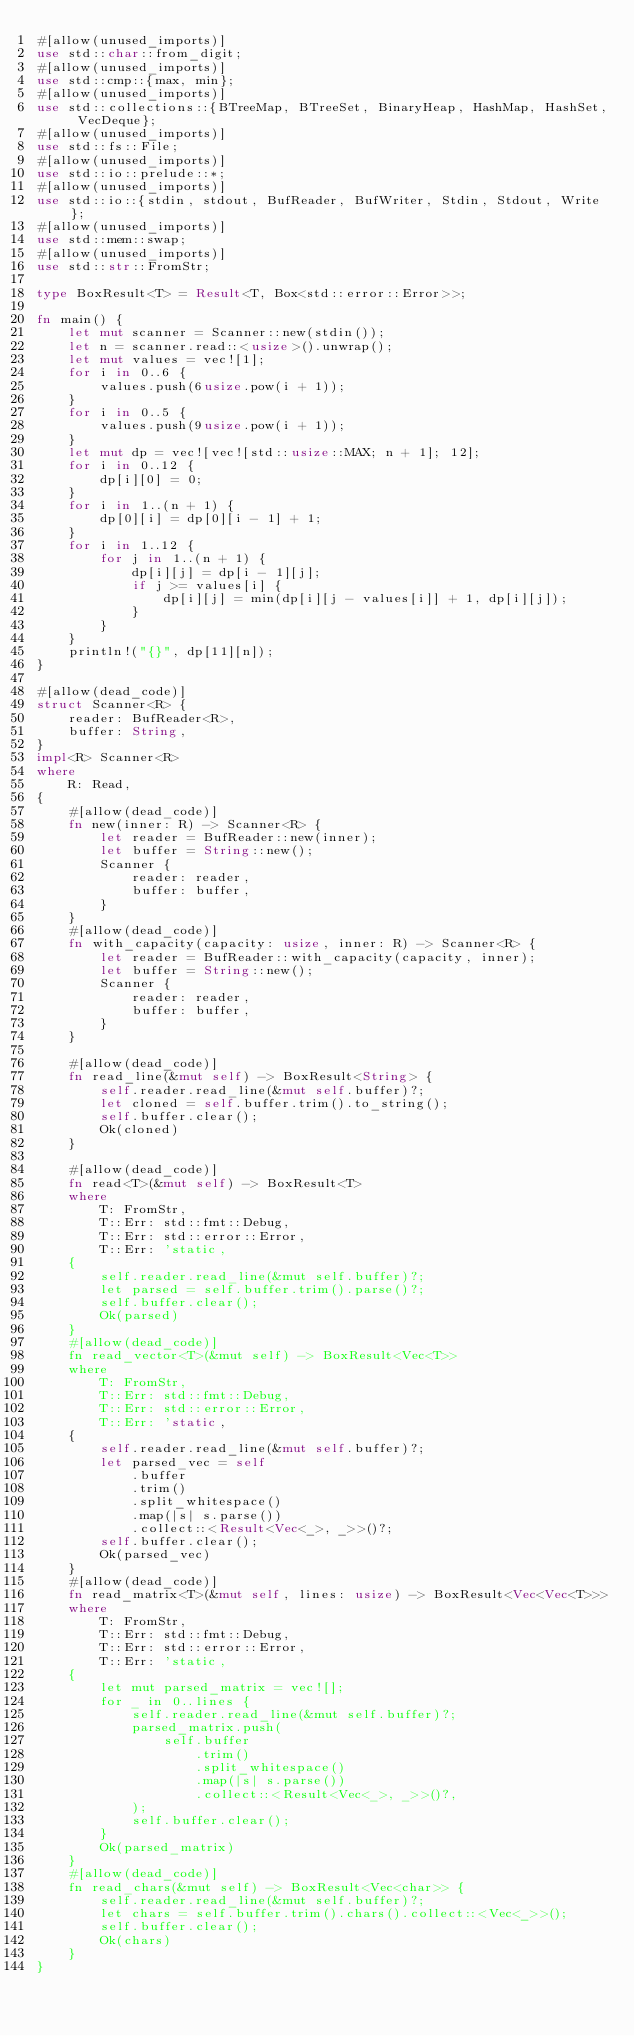Convert code to text. <code><loc_0><loc_0><loc_500><loc_500><_Rust_>#[allow(unused_imports)]
use std::char::from_digit;
#[allow(unused_imports)]
use std::cmp::{max, min};
#[allow(unused_imports)]
use std::collections::{BTreeMap, BTreeSet, BinaryHeap, HashMap, HashSet, VecDeque};
#[allow(unused_imports)]
use std::fs::File;
#[allow(unused_imports)]
use std::io::prelude::*;
#[allow(unused_imports)]
use std::io::{stdin, stdout, BufReader, BufWriter, Stdin, Stdout, Write};
#[allow(unused_imports)]
use std::mem::swap;
#[allow(unused_imports)]
use std::str::FromStr;

type BoxResult<T> = Result<T, Box<std::error::Error>>;

fn main() {
    let mut scanner = Scanner::new(stdin());
    let n = scanner.read::<usize>().unwrap();
    let mut values = vec![1];
    for i in 0..6 {
        values.push(6usize.pow(i + 1));
    }
    for i in 0..5 {
        values.push(9usize.pow(i + 1));
    }
    let mut dp = vec![vec![std::usize::MAX; n + 1]; 12];
    for i in 0..12 {
        dp[i][0] = 0;
    }
    for i in 1..(n + 1) {
        dp[0][i] = dp[0][i - 1] + 1;
    }
    for i in 1..12 {
        for j in 1..(n + 1) {
            dp[i][j] = dp[i - 1][j];
            if j >= values[i] {
                dp[i][j] = min(dp[i][j - values[i]] + 1, dp[i][j]);
            }
        }
    }
    println!("{}", dp[11][n]);
}

#[allow(dead_code)]
struct Scanner<R> {
    reader: BufReader<R>,
    buffer: String,
}
impl<R> Scanner<R>
where
    R: Read,
{
    #[allow(dead_code)]
    fn new(inner: R) -> Scanner<R> {
        let reader = BufReader::new(inner);
        let buffer = String::new();
        Scanner {
            reader: reader,
            buffer: buffer,
        }
    }
    #[allow(dead_code)]
    fn with_capacity(capacity: usize, inner: R) -> Scanner<R> {
        let reader = BufReader::with_capacity(capacity, inner);
        let buffer = String::new();
        Scanner {
            reader: reader,
            buffer: buffer,
        }
    }

    #[allow(dead_code)]
    fn read_line(&mut self) -> BoxResult<String> {
        self.reader.read_line(&mut self.buffer)?;
        let cloned = self.buffer.trim().to_string();
        self.buffer.clear();
        Ok(cloned)
    }

    #[allow(dead_code)]
    fn read<T>(&mut self) -> BoxResult<T>
    where
        T: FromStr,
        T::Err: std::fmt::Debug,
        T::Err: std::error::Error,
        T::Err: 'static,
    {
        self.reader.read_line(&mut self.buffer)?;
        let parsed = self.buffer.trim().parse()?;
        self.buffer.clear();
        Ok(parsed)
    }
    #[allow(dead_code)]
    fn read_vector<T>(&mut self) -> BoxResult<Vec<T>>
    where
        T: FromStr,
        T::Err: std::fmt::Debug,
        T::Err: std::error::Error,
        T::Err: 'static,
    {
        self.reader.read_line(&mut self.buffer)?;
        let parsed_vec = self
            .buffer
            .trim()
            .split_whitespace()
            .map(|s| s.parse())
            .collect::<Result<Vec<_>, _>>()?;
        self.buffer.clear();
        Ok(parsed_vec)
    }
    #[allow(dead_code)]
    fn read_matrix<T>(&mut self, lines: usize) -> BoxResult<Vec<Vec<T>>>
    where
        T: FromStr,
        T::Err: std::fmt::Debug,
        T::Err: std::error::Error,
        T::Err: 'static,
    {
        let mut parsed_matrix = vec![];
        for _ in 0..lines {
            self.reader.read_line(&mut self.buffer)?;
            parsed_matrix.push(
                self.buffer
                    .trim()
                    .split_whitespace()
                    .map(|s| s.parse())
                    .collect::<Result<Vec<_>, _>>()?,
            );
            self.buffer.clear();
        }
        Ok(parsed_matrix)
    }
    #[allow(dead_code)]
    fn read_chars(&mut self) -> BoxResult<Vec<char>> {
        self.reader.read_line(&mut self.buffer)?;
        let chars = self.buffer.trim().chars().collect::<Vec<_>>();
        self.buffer.clear();
        Ok(chars)
    }
}
</code> 